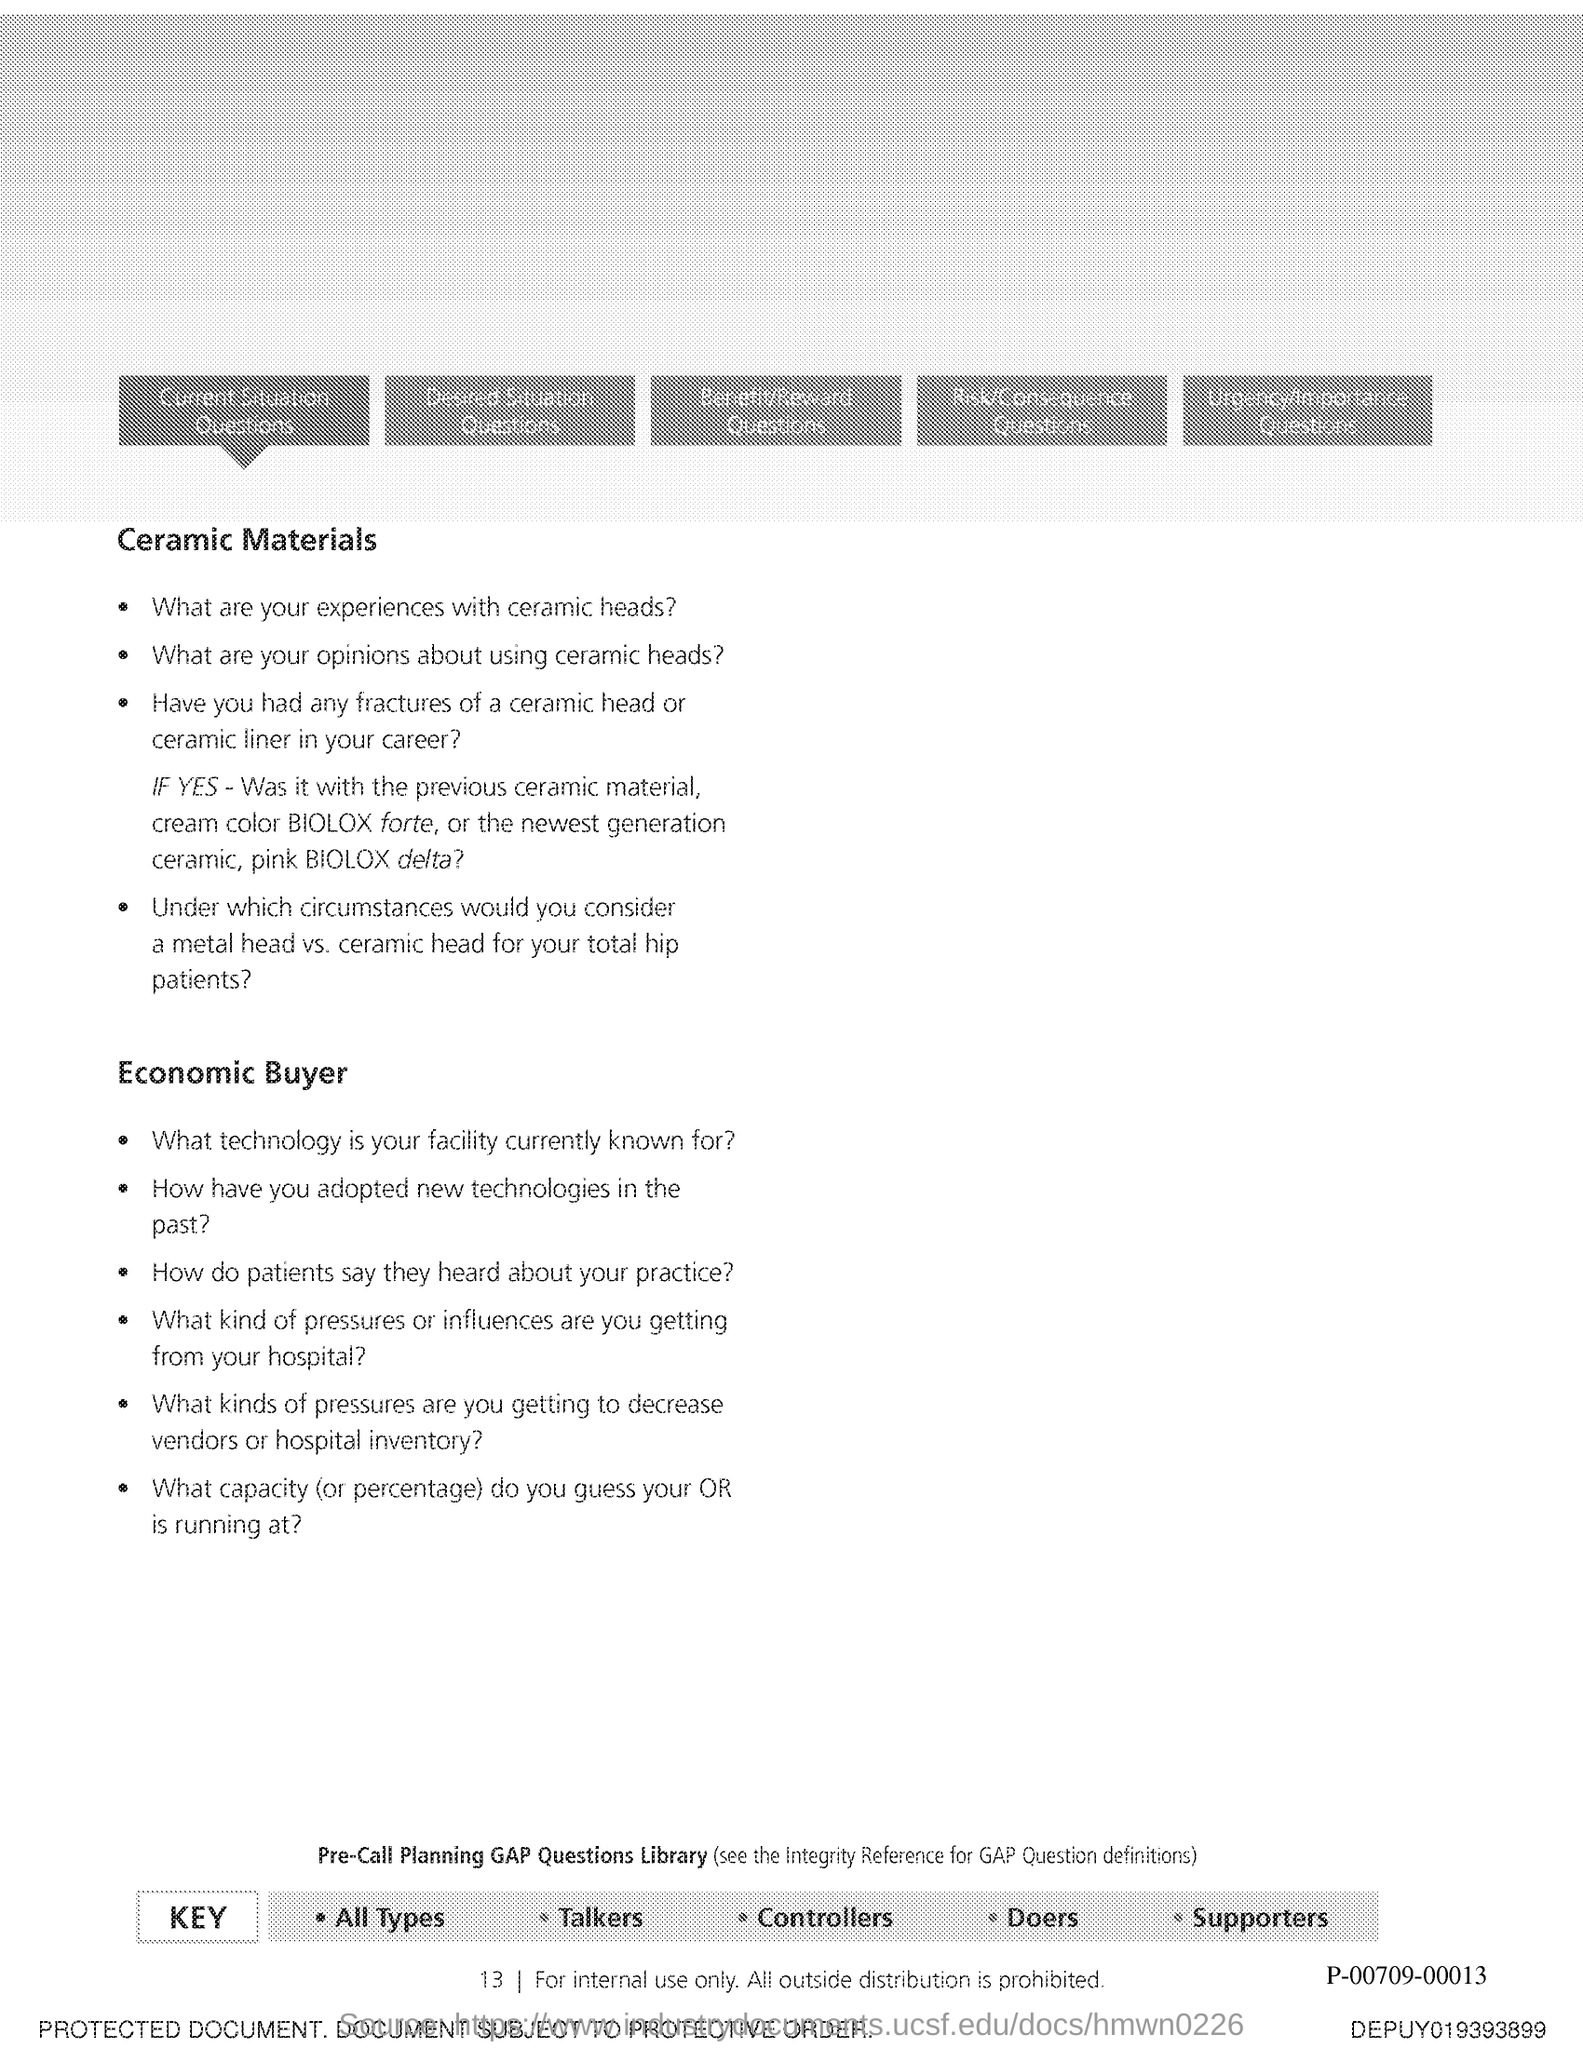Indicate a few pertinent items in this graphic. The page number is 13. 